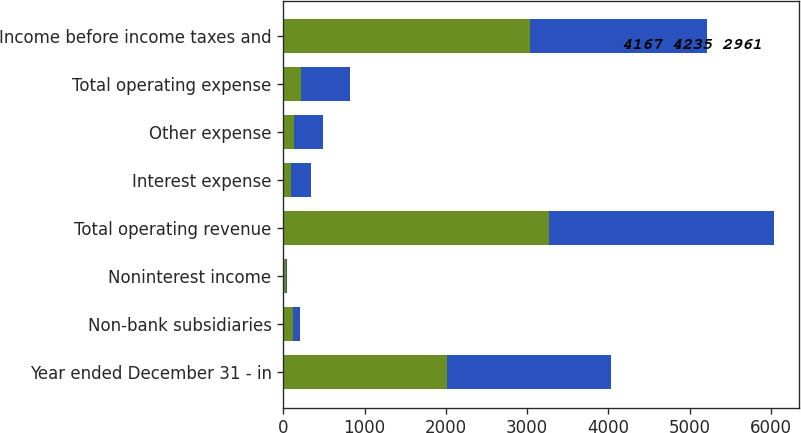Convert chart to OTSL. <chart><loc_0><loc_0><loc_500><loc_500><stacked_bar_chart><ecel><fcel>Year ended December 31 - in<fcel>Non-bank subsidiaries<fcel>Noninterest income<fcel>Total operating revenue<fcel>Interest expense<fcel>Other expense<fcel>Total operating expense<fcel>Income before income taxes and<nl><fcel>nan<fcel>2014<fcel>115<fcel>30<fcel>3264<fcel>97<fcel>127<fcel>224<fcel>3040<nl><fcel>4167 4235 2961<fcel>2012<fcel>91<fcel>22<fcel>2773<fcel>242<fcel>359<fcel>601<fcel>2172<nl></chart> 